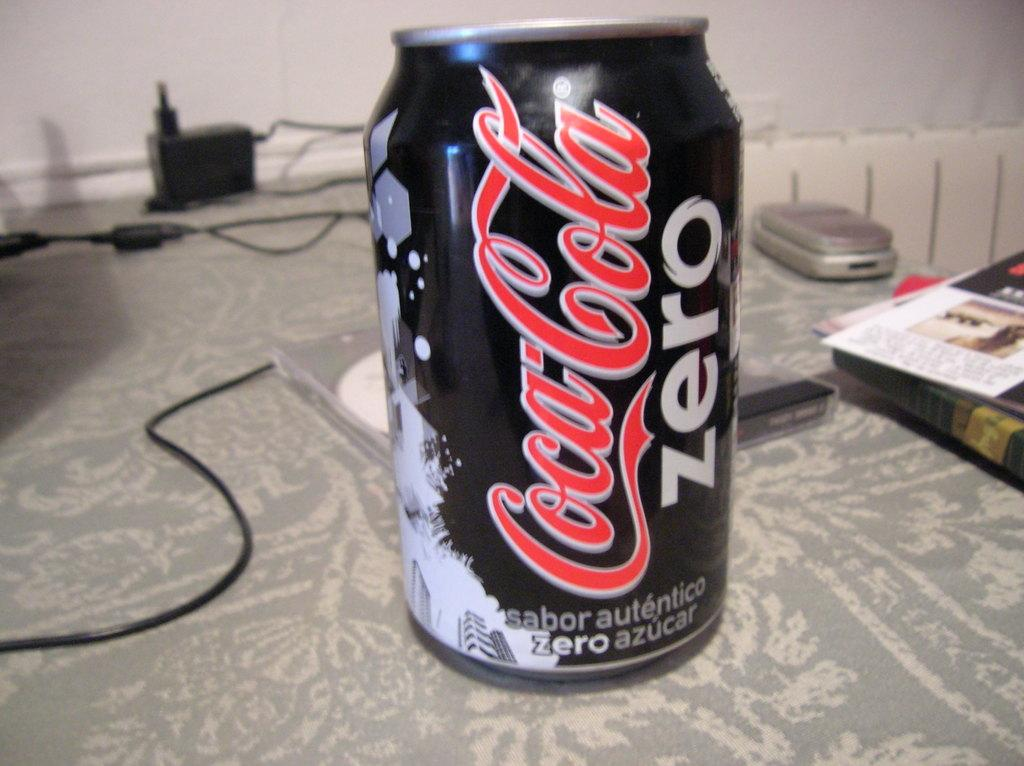<image>
Provide a brief description of the given image. A Coca Cola Zero can sitting on a table with a cell phone in the background. 